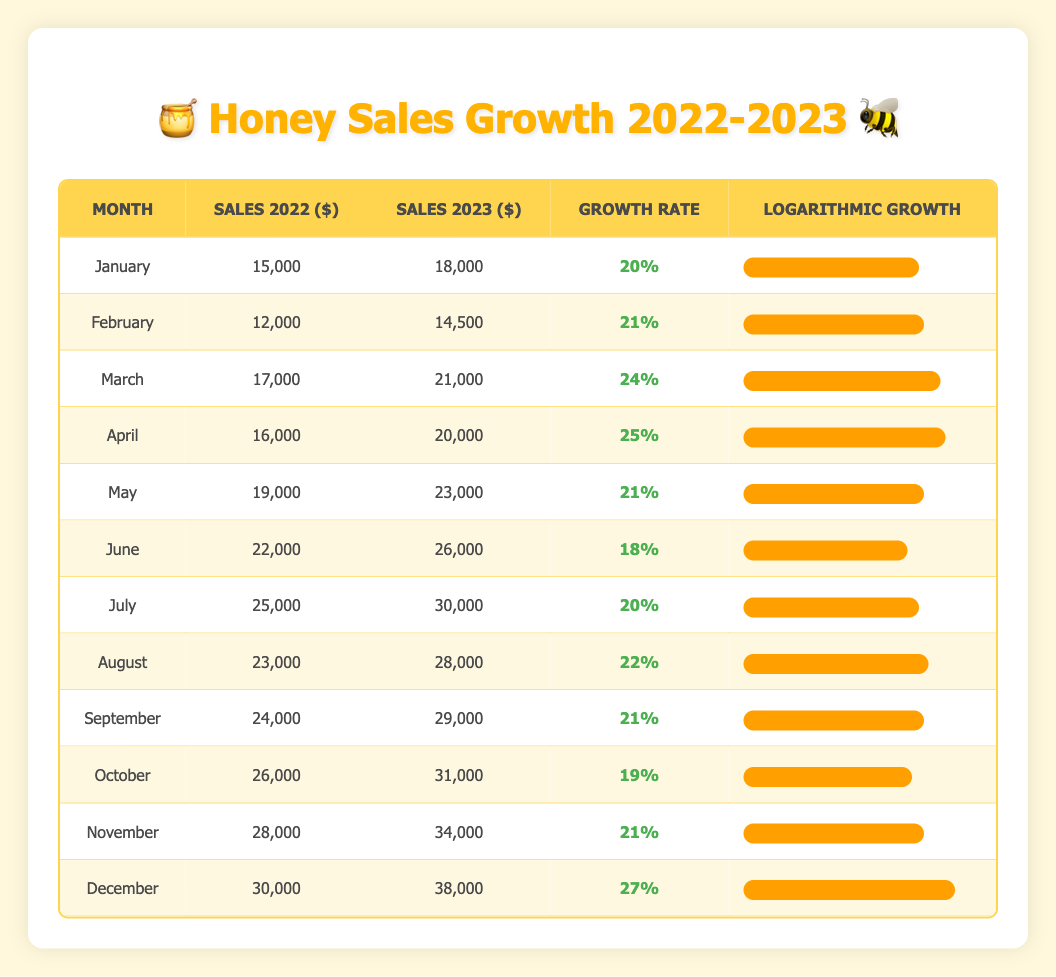What was the sales amount for honey products in June 2023? Referring to the table, the sales amount for June 2023 is directly listed in the "Sales 2023 ($)" column for June, which is 26,000 dollars.
Answer: 26,000 Which month had the highest growth rate? Looking through the "Growth Rate" column, the month with the highest growth rate is December, which had a growth rate of 27%.
Answer: December What is the average sales growth rate from January to March? To find the average, sum the growth rates for January (20%), February (21%), and March (24%) which equals 65%. Then divide that sum by 3, resulting in an average growth rate of 21.67%.
Answer: 21.67% Did the sales in November exceed those in October? By comparing the "Sales 2023 ($)" values, November's sales (34,000 dollars) are greater than October's sales (31,000 dollars) which confirms that it is true.
Answer: Yes What was the total sales amount for all months in 2022? Adding the sales amounts from "Sales 2022 ($)" for all months: 15,000 + 12,000 + 17,000 + 16,000 + 19,000 + 22,000 + 25,000 + 23,000 + 24,000 + 26,000 + 28,000 + 30,000 =  306,000.
Answer: 306,000 Which month showed the least increase in sales compared to the previous year? By checking the growth rates, June has the lowest at 18%, indicating it had the least increase in sales.
Answer: June How much did sales grow from July 2022 to July 2023? The sales for July 2022 were 25,000 dollars and July 2023 were 30,000 dollars; the difference is 30,000 - 25,000 = 5,000 dollars.
Answer: 5,000 If we consider the sales growth rates in the second half of the year, what is the average growth rate from July to December? Adding the growth rates from July (20%), August (22%), September (21%), October (19%), November (21%), and December (27%) gives a total of 130%. Dividing by 6 gives an average growth rate of approximately 21.67%.
Answer: 21.67% Was there a month where the growth rate was exactly 21%? Yes, both February and November have a growth rate of 21%, confirming the fact is true.
Answer: Yes 